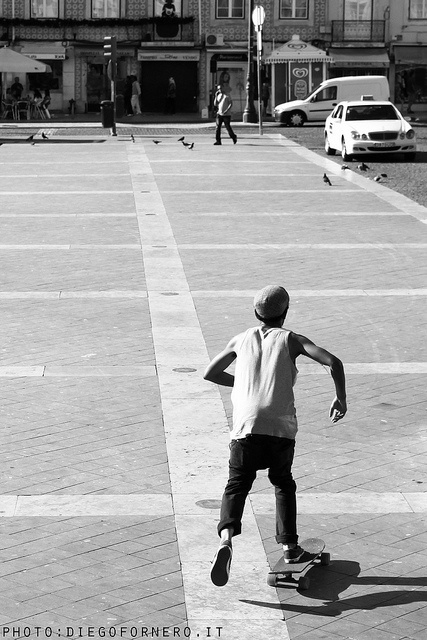Describe the objects in this image and their specific colors. I can see people in gray, black, lightgray, and darkgray tones, car in gray, white, black, and darkgray tones, truck in gray, darkgray, black, and white tones, skateboard in gray, black, darkgray, and lightgray tones, and people in gray, black, lightgray, and darkgray tones in this image. 